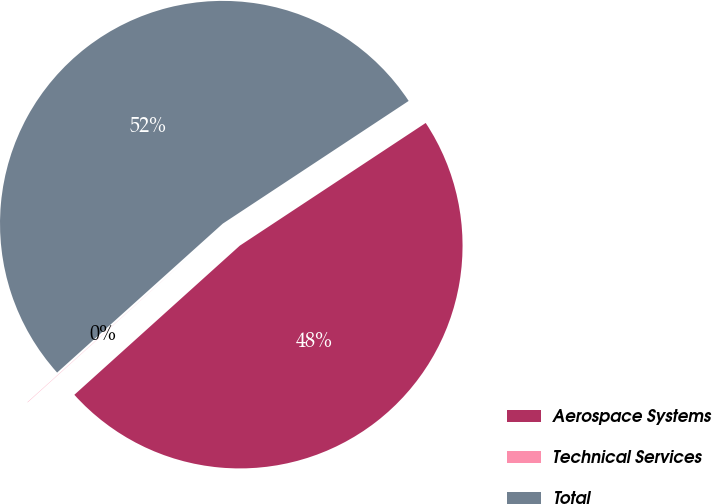Convert chart to OTSL. <chart><loc_0><loc_0><loc_500><loc_500><pie_chart><fcel>Aerospace Systems<fcel>Technical Services<fcel>Total<nl><fcel>47.61%<fcel>0.02%<fcel>52.37%<nl></chart> 